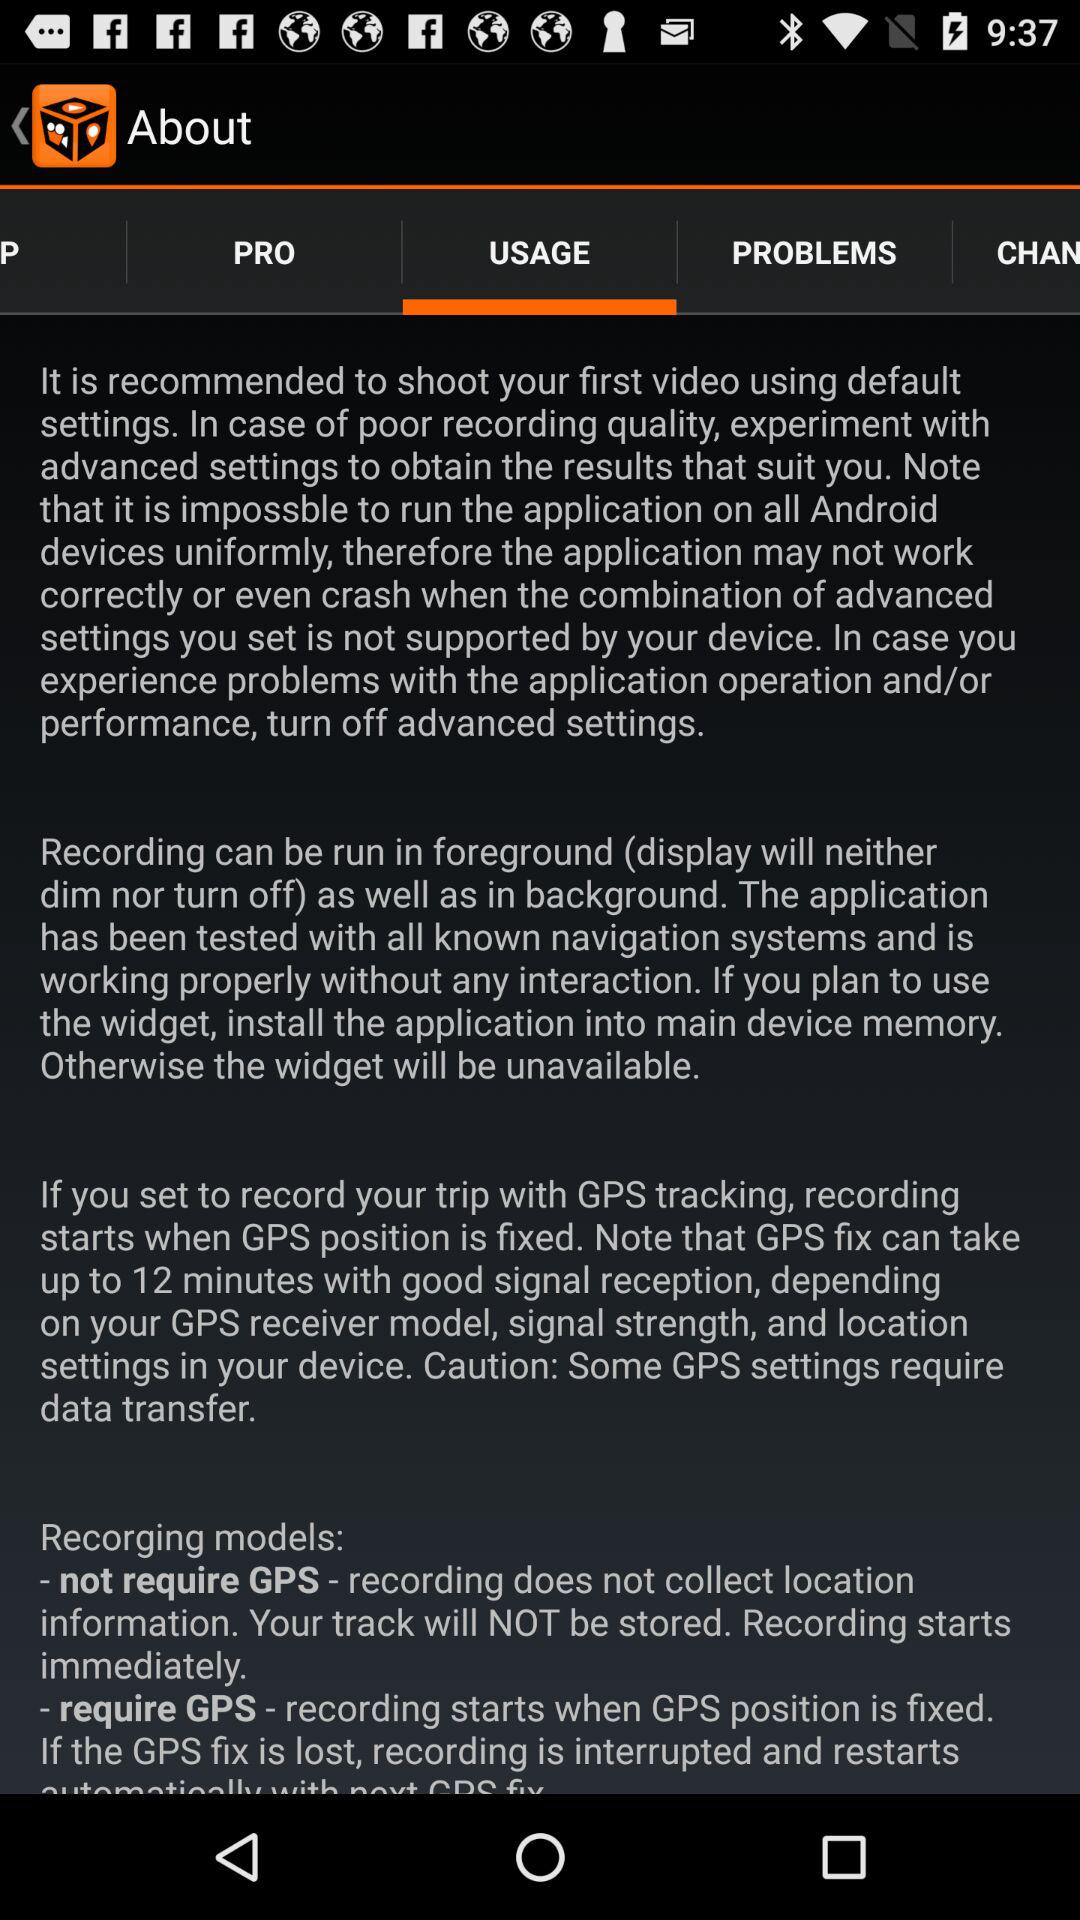What tab has been selected? The tab that has been selected is "USAGE". 